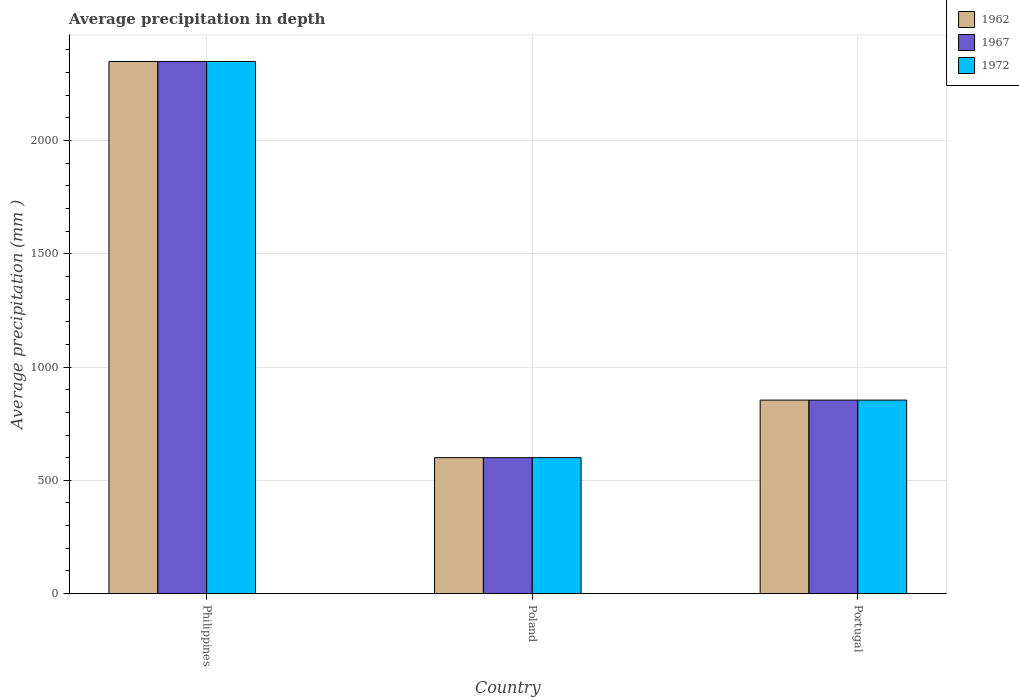How many different coloured bars are there?
Your answer should be very brief. 3. How many bars are there on the 1st tick from the left?
Provide a short and direct response. 3. How many bars are there on the 2nd tick from the right?
Ensure brevity in your answer.  3. In how many cases, is the number of bars for a given country not equal to the number of legend labels?
Your response must be concise. 0. What is the average precipitation in 1967 in Philippines?
Your answer should be very brief. 2348. Across all countries, what is the maximum average precipitation in 1962?
Offer a very short reply. 2348. Across all countries, what is the minimum average precipitation in 1972?
Give a very brief answer. 600. In which country was the average precipitation in 1962 minimum?
Make the answer very short. Poland. What is the total average precipitation in 1967 in the graph?
Your response must be concise. 3802. What is the difference between the average precipitation in 1967 in Poland and that in Portugal?
Provide a short and direct response. -254. What is the difference between the average precipitation in 1972 in Portugal and the average precipitation in 1962 in Philippines?
Your answer should be very brief. -1494. What is the average average precipitation in 1962 per country?
Your answer should be compact. 1267.33. What is the ratio of the average precipitation in 1967 in Philippines to that in Portugal?
Offer a very short reply. 2.75. Is the average precipitation in 1967 in Philippines less than that in Portugal?
Your answer should be very brief. No. Is the difference between the average precipitation in 1967 in Philippines and Poland greater than the difference between the average precipitation in 1962 in Philippines and Poland?
Your answer should be very brief. No. What is the difference between the highest and the second highest average precipitation in 1967?
Give a very brief answer. -1748. What is the difference between the highest and the lowest average precipitation in 1967?
Keep it short and to the point. 1748. Is the sum of the average precipitation in 1972 in Philippines and Portugal greater than the maximum average precipitation in 1962 across all countries?
Give a very brief answer. Yes. What does the 1st bar from the left in Philippines represents?
Offer a very short reply. 1962. What does the 2nd bar from the right in Portugal represents?
Offer a very short reply. 1967. How many countries are there in the graph?
Provide a succinct answer. 3. What is the difference between two consecutive major ticks on the Y-axis?
Offer a terse response. 500. Does the graph contain any zero values?
Your response must be concise. No. How are the legend labels stacked?
Provide a short and direct response. Vertical. What is the title of the graph?
Provide a short and direct response. Average precipitation in depth. What is the label or title of the Y-axis?
Provide a succinct answer. Average precipitation (mm ). What is the Average precipitation (mm ) in 1962 in Philippines?
Keep it short and to the point. 2348. What is the Average precipitation (mm ) of 1967 in Philippines?
Offer a very short reply. 2348. What is the Average precipitation (mm ) in 1972 in Philippines?
Provide a succinct answer. 2348. What is the Average precipitation (mm ) of 1962 in Poland?
Give a very brief answer. 600. What is the Average precipitation (mm ) of 1967 in Poland?
Offer a very short reply. 600. What is the Average precipitation (mm ) in 1972 in Poland?
Keep it short and to the point. 600. What is the Average precipitation (mm ) of 1962 in Portugal?
Make the answer very short. 854. What is the Average precipitation (mm ) of 1967 in Portugal?
Make the answer very short. 854. What is the Average precipitation (mm ) of 1972 in Portugal?
Keep it short and to the point. 854. Across all countries, what is the maximum Average precipitation (mm ) of 1962?
Ensure brevity in your answer.  2348. Across all countries, what is the maximum Average precipitation (mm ) of 1967?
Your answer should be very brief. 2348. Across all countries, what is the maximum Average precipitation (mm ) of 1972?
Make the answer very short. 2348. Across all countries, what is the minimum Average precipitation (mm ) in 1962?
Your response must be concise. 600. Across all countries, what is the minimum Average precipitation (mm ) of 1967?
Provide a succinct answer. 600. Across all countries, what is the minimum Average precipitation (mm ) in 1972?
Your answer should be compact. 600. What is the total Average precipitation (mm ) of 1962 in the graph?
Ensure brevity in your answer.  3802. What is the total Average precipitation (mm ) of 1967 in the graph?
Provide a succinct answer. 3802. What is the total Average precipitation (mm ) in 1972 in the graph?
Your answer should be compact. 3802. What is the difference between the Average precipitation (mm ) of 1962 in Philippines and that in Poland?
Ensure brevity in your answer.  1748. What is the difference between the Average precipitation (mm ) of 1967 in Philippines and that in Poland?
Ensure brevity in your answer.  1748. What is the difference between the Average precipitation (mm ) in 1972 in Philippines and that in Poland?
Give a very brief answer. 1748. What is the difference between the Average precipitation (mm ) in 1962 in Philippines and that in Portugal?
Keep it short and to the point. 1494. What is the difference between the Average precipitation (mm ) in 1967 in Philippines and that in Portugal?
Offer a very short reply. 1494. What is the difference between the Average precipitation (mm ) in 1972 in Philippines and that in Portugal?
Ensure brevity in your answer.  1494. What is the difference between the Average precipitation (mm ) of 1962 in Poland and that in Portugal?
Make the answer very short. -254. What is the difference between the Average precipitation (mm ) in 1967 in Poland and that in Portugal?
Your response must be concise. -254. What is the difference between the Average precipitation (mm ) of 1972 in Poland and that in Portugal?
Your response must be concise. -254. What is the difference between the Average precipitation (mm ) in 1962 in Philippines and the Average precipitation (mm ) in 1967 in Poland?
Your response must be concise. 1748. What is the difference between the Average precipitation (mm ) of 1962 in Philippines and the Average precipitation (mm ) of 1972 in Poland?
Ensure brevity in your answer.  1748. What is the difference between the Average precipitation (mm ) of 1967 in Philippines and the Average precipitation (mm ) of 1972 in Poland?
Give a very brief answer. 1748. What is the difference between the Average precipitation (mm ) in 1962 in Philippines and the Average precipitation (mm ) in 1967 in Portugal?
Provide a short and direct response. 1494. What is the difference between the Average precipitation (mm ) of 1962 in Philippines and the Average precipitation (mm ) of 1972 in Portugal?
Ensure brevity in your answer.  1494. What is the difference between the Average precipitation (mm ) of 1967 in Philippines and the Average precipitation (mm ) of 1972 in Portugal?
Offer a very short reply. 1494. What is the difference between the Average precipitation (mm ) of 1962 in Poland and the Average precipitation (mm ) of 1967 in Portugal?
Ensure brevity in your answer.  -254. What is the difference between the Average precipitation (mm ) of 1962 in Poland and the Average precipitation (mm ) of 1972 in Portugal?
Make the answer very short. -254. What is the difference between the Average precipitation (mm ) of 1967 in Poland and the Average precipitation (mm ) of 1972 in Portugal?
Offer a terse response. -254. What is the average Average precipitation (mm ) in 1962 per country?
Provide a succinct answer. 1267.33. What is the average Average precipitation (mm ) of 1967 per country?
Keep it short and to the point. 1267.33. What is the average Average precipitation (mm ) of 1972 per country?
Offer a very short reply. 1267.33. What is the difference between the Average precipitation (mm ) in 1962 and Average precipitation (mm ) in 1967 in Philippines?
Provide a succinct answer. 0. What is the difference between the Average precipitation (mm ) in 1962 and Average precipitation (mm ) in 1972 in Poland?
Your answer should be compact. 0. What is the ratio of the Average precipitation (mm ) of 1962 in Philippines to that in Poland?
Ensure brevity in your answer.  3.91. What is the ratio of the Average precipitation (mm ) of 1967 in Philippines to that in Poland?
Ensure brevity in your answer.  3.91. What is the ratio of the Average precipitation (mm ) of 1972 in Philippines to that in Poland?
Your answer should be very brief. 3.91. What is the ratio of the Average precipitation (mm ) of 1962 in Philippines to that in Portugal?
Ensure brevity in your answer.  2.75. What is the ratio of the Average precipitation (mm ) of 1967 in Philippines to that in Portugal?
Make the answer very short. 2.75. What is the ratio of the Average precipitation (mm ) in 1972 in Philippines to that in Portugal?
Provide a short and direct response. 2.75. What is the ratio of the Average precipitation (mm ) in 1962 in Poland to that in Portugal?
Give a very brief answer. 0.7. What is the ratio of the Average precipitation (mm ) in 1967 in Poland to that in Portugal?
Your response must be concise. 0.7. What is the ratio of the Average precipitation (mm ) in 1972 in Poland to that in Portugal?
Keep it short and to the point. 0.7. What is the difference between the highest and the second highest Average precipitation (mm ) of 1962?
Provide a short and direct response. 1494. What is the difference between the highest and the second highest Average precipitation (mm ) in 1967?
Provide a succinct answer. 1494. What is the difference between the highest and the second highest Average precipitation (mm ) in 1972?
Make the answer very short. 1494. What is the difference between the highest and the lowest Average precipitation (mm ) in 1962?
Your answer should be compact. 1748. What is the difference between the highest and the lowest Average precipitation (mm ) of 1967?
Your answer should be compact. 1748. What is the difference between the highest and the lowest Average precipitation (mm ) of 1972?
Offer a very short reply. 1748. 